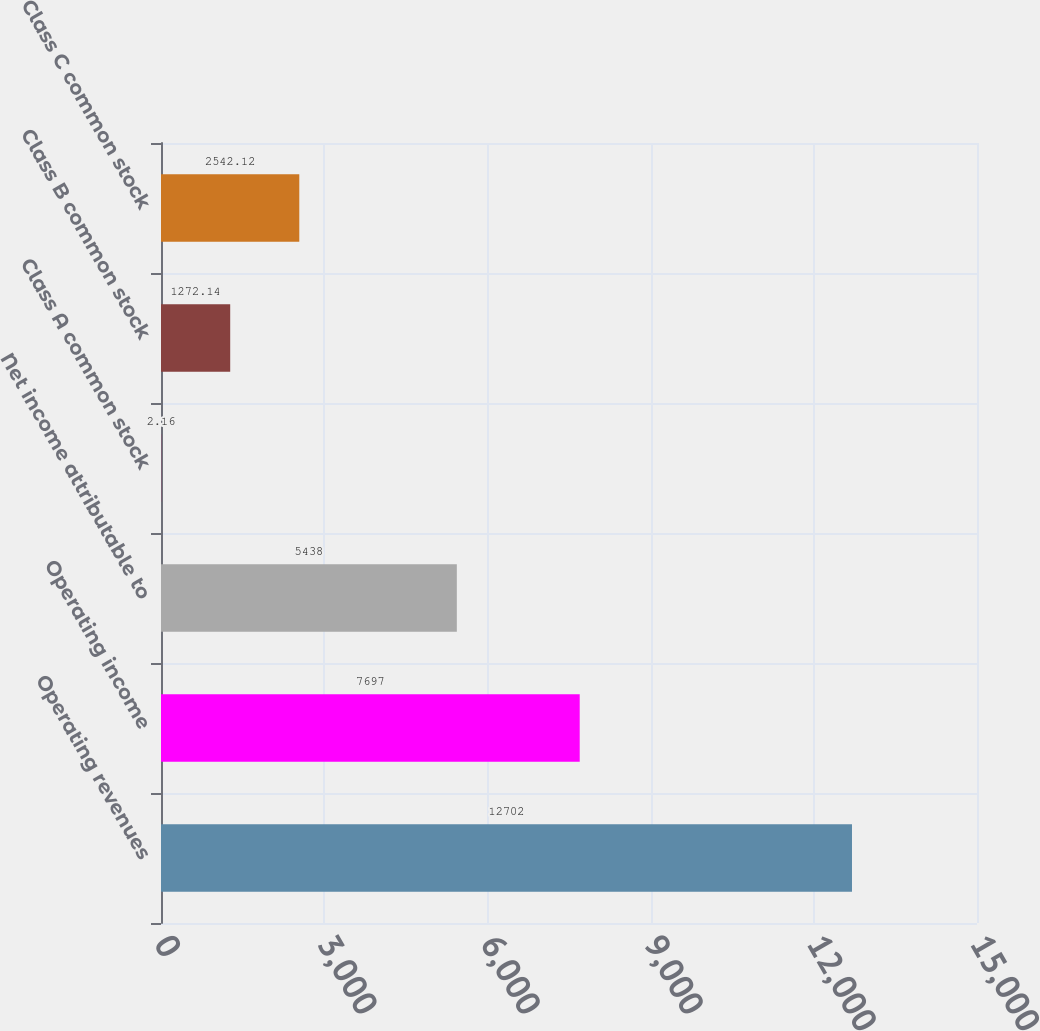Convert chart to OTSL. <chart><loc_0><loc_0><loc_500><loc_500><bar_chart><fcel>Operating revenues<fcel>Operating income<fcel>Net income attributable to<fcel>Class A common stock<fcel>Class B common stock<fcel>Class C common stock<nl><fcel>12702<fcel>7697<fcel>5438<fcel>2.16<fcel>1272.14<fcel>2542.12<nl></chart> 